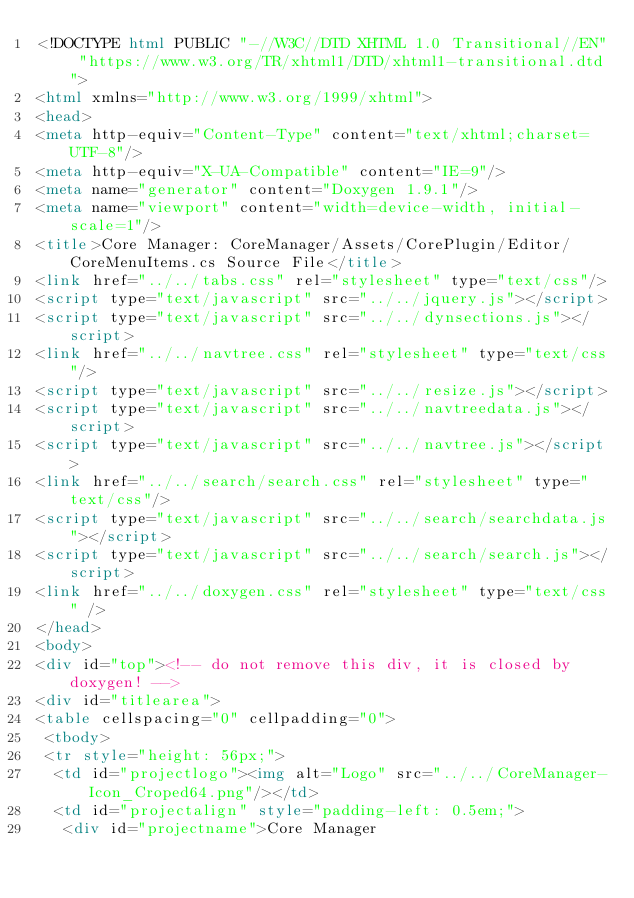Convert code to text. <code><loc_0><loc_0><loc_500><loc_500><_HTML_><!DOCTYPE html PUBLIC "-//W3C//DTD XHTML 1.0 Transitional//EN" "https://www.w3.org/TR/xhtml1/DTD/xhtml1-transitional.dtd">
<html xmlns="http://www.w3.org/1999/xhtml">
<head>
<meta http-equiv="Content-Type" content="text/xhtml;charset=UTF-8"/>
<meta http-equiv="X-UA-Compatible" content="IE=9"/>
<meta name="generator" content="Doxygen 1.9.1"/>
<meta name="viewport" content="width=device-width, initial-scale=1"/>
<title>Core Manager: CoreManager/Assets/CorePlugin/Editor/CoreMenuItems.cs Source File</title>
<link href="../../tabs.css" rel="stylesheet" type="text/css"/>
<script type="text/javascript" src="../../jquery.js"></script>
<script type="text/javascript" src="../../dynsections.js"></script>
<link href="../../navtree.css" rel="stylesheet" type="text/css"/>
<script type="text/javascript" src="../../resize.js"></script>
<script type="text/javascript" src="../../navtreedata.js"></script>
<script type="text/javascript" src="../../navtree.js"></script>
<link href="../../search/search.css" rel="stylesheet" type="text/css"/>
<script type="text/javascript" src="../../search/searchdata.js"></script>
<script type="text/javascript" src="../../search/search.js"></script>
<link href="../../doxygen.css" rel="stylesheet" type="text/css" />
</head>
<body>
<div id="top"><!-- do not remove this div, it is closed by doxygen! -->
<div id="titlearea">
<table cellspacing="0" cellpadding="0">
 <tbody>
 <tr style="height: 56px;">
  <td id="projectlogo"><img alt="Logo" src="../../CoreManager-Icon_Croped64.png"/></td>
  <td id="projectalign" style="padding-left: 0.5em;">
   <div id="projectname">Core Manager</code> 